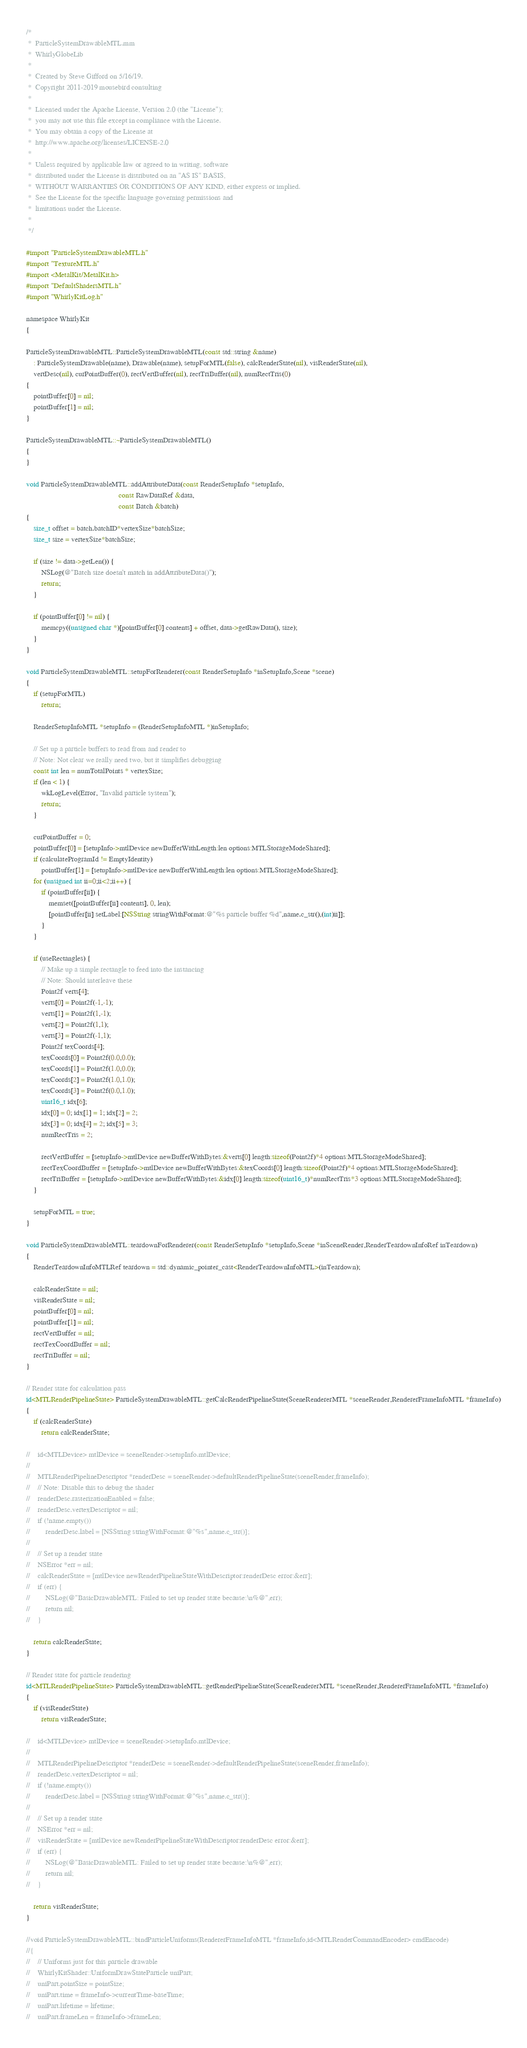<code> <loc_0><loc_0><loc_500><loc_500><_ObjectiveC_>/*
 *  ParticleSystemDrawableMTL.mm
 *  WhirlyGlobeLib
 *
 *  Created by Steve Gifford on 5/16/19.
 *  Copyright 2011-2019 mousebird consulting
 *
 *  Licensed under the Apache License, Version 2.0 (the "License");
 *  you may not use this file except in compliance with the License.
 *  You may obtain a copy of the License at
 *  http://www.apache.org/licenses/LICENSE-2.0
 *
 *  Unless required by applicable law or agreed to in writing, software
 *  distributed under the License is distributed on an "AS IS" BASIS,
 *  WITHOUT WARRANTIES OR CONDITIONS OF ANY KIND, either express or implied.
 *  See the License for the specific language governing permissions and
 *  limitations under the License.
 *
 */

#import "ParticleSystemDrawableMTL.h"
#import "TextureMTL.h"
#import <MetalKit/MetalKit.h>
#import "DefaultShadersMTL.h"
#import "WhirlyKitLog.h"

namespace WhirlyKit
{

ParticleSystemDrawableMTL::ParticleSystemDrawableMTL(const std::string &name)
    : ParticleSystemDrawable(name), Drawable(name), setupForMTL(false), calcRenderState(nil), visRenderState(nil),
    vertDesc(nil), curPointBuffer(0), rectVertBuffer(nil), rectTriBuffer(nil), numRectTris(0)
{
    pointBuffer[0] = nil;
    pointBuffer[1] = nil;
}

ParticleSystemDrawableMTL::~ParticleSystemDrawableMTL()
{
}

void ParticleSystemDrawableMTL::addAttributeData(const RenderSetupInfo *setupInfo,
                                                 const RawDataRef &data,
                                                 const Batch &batch)
{
    size_t offset = batch.batchID*vertexSize*batchSize;
    size_t size = vertexSize*batchSize;
    
    if (size != data->getLen()) {
        NSLog(@"Batch size doesn't match in addAttributeData()");
        return;
    }
    
    if (pointBuffer[0] != nil) {
        memcpy((unsigned char *)[pointBuffer[0] contents] + offset, data->getRawData(), size);
    }
}

void ParticleSystemDrawableMTL::setupForRenderer(const RenderSetupInfo *inSetupInfo,Scene *scene)
{
    if (setupForMTL)
        return;

    RenderSetupInfoMTL *setupInfo = (RenderSetupInfoMTL *)inSetupInfo;
    
    // Set up a particle buffers to read from and render to
    // Note: Not clear we really need two, but it simplifies debugging
    const int len = numTotalPoints * vertexSize;
    if (len < 1) {
        wkLogLevel(Error, "Invalid particle system");
        return;
    }
    
    curPointBuffer = 0;
    pointBuffer[0] = [setupInfo->mtlDevice newBufferWithLength:len options:MTLStorageModeShared];
    if (calculateProgramId != EmptyIdentity)
        pointBuffer[1] = [setupInfo->mtlDevice newBufferWithLength:len options:MTLStorageModeShared];
    for (unsigned int ii=0;ii<2;ii++) {
        if (pointBuffer[ii]) {
            memset([pointBuffer[ii] contents], 0, len);
            [pointBuffer[ii] setLabel:[NSString stringWithFormat:@"%s particle buffer %d",name.c_str(),(int)ii]];
        }
    }
    
    if (useRectangles) {
        // Make up a simple rectangle to feed into the instancing
        // Note: Should interleave these
        Point2f verts[4];
        verts[0] = Point2f(-1,-1);
        verts[1] = Point2f(1,-1);
        verts[2] = Point2f(1,1);
        verts[3] = Point2f(-1,1);
        Point2f texCoords[4];
        texCoords[0] = Point2f(0.0,0.0);
        texCoords[1] = Point2f(1.0,0.0);
        texCoords[2] = Point2f(1.0,1.0);
        texCoords[3] = Point2f(0.0,1.0);
        uint16_t idx[6];
        idx[0] = 0; idx[1] = 1; idx[2] = 2;
        idx[3] = 0; idx[4] = 2; idx[5] = 3;
        numRectTris = 2;
        
        rectVertBuffer = [setupInfo->mtlDevice newBufferWithBytes:&verts[0] length:sizeof(Point2f)*4 options:MTLStorageModeShared];
        rectTexCoordBuffer = [setupInfo->mtlDevice newBufferWithBytes:&texCoords[0] length:sizeof(Point2f)*4 options:MTLStorageModeShared];
        rectTriBuffer = [setupInfo->mtlDevice newBufferWithBytes:&idx[0] length:sizeof(uint16_t)*numRectTris*3 options:MTLStorageModeShared];
    }

    setupForMTL = true;
}

void ParticleSystemDrawableMTL::teardownForRenderer(const RenderSetupInfo *setupInfo,Scene *inSceneRender,RenderTeardownInfoRef inTeardown)
{
    RenderTeardownInfoMTLRef teardown = std::dynamic_pointer_cast<RenderTeardownInfoMTL>(inTeardown);

    calcRenderState = nil;
    visRenderState = nil;
    pointBuffer[0] = nil;
    pointBuffer[1] = nil;
    rectVertBuffer = nil;
    rectTexCoordBuffer = nil;
    rectTriBuffer = nil;
}
    
// Render state for calculation pass
id<MTLRenderPipelineState> ParticleSystemDrawableMTL::getCalcRenderPipelineState(SceneRendererMTL *sceneRender,RendererFrameInfoMTL *frameInfo)
{
    if (calcRenderState)
        return calcRenderState;
    
//    id<MTLDevice> mtlDevice = sceneRender->setupInfo.mtlDevice;
//    
//    MTLRenderPipelineDescriptor *renderDesc = sceneRender->defaultRenderPipelineState(sceneRender,frameInfo);
//    // Note: Disable this to debug the shader
//    renderDesc.rasterizationEnabled = false;
//    renderDesc.vertexDescriptor = nil;
//    if (!name.empty())
//        renderDesc.label = [NSString stringWithFormat:@"%s",name.c_str()];
//    
//    // Set up a render state
//    NSError *err = nil;
//    calcRenderState = [mtlDevice newRenderPipelineStateWithDescriptor:renderDesc error:&err];
//    if (err) {
//        NSLog(@"BasicDrawableMTL: Failed to set up render state because:\n%@",err);
//        return nil;
//    }
    
    return calcRenderState;
}
    
// Render state for particle rendering
id<MTLRenderPipelineState> ParticleSystemDrawableMTL::getRenderPipelineState(SceneRendererMTL *sceneRender,RendererFrameInfoMTL *frameInfo)
{
    if (visRenderState)
        return visRenderState;
    
//    id<MTLDevice> mtlDevice = sceneRender->setupInfo.mtlDevice;
//
//    MTLRenderPipelineDescriptor *renderDesc = sceneRender->defaultRenderPipelineState(sceneRender,frameInfo);
//    renderDesc.vertexDescriptor = nil;
//    if (!name.empty())
//        renderDesc.label = [NSString stringWithFormat:@"%s",name.c_str()];
//
//    // Set up a render state
//    NSError *err = nil;
//    visRenderState = [mtlDevice newRenderPipelineStateWithDescriptor:renderDesc error:&err];
//    if (err) {
//        NSLog(@"BasicDrawableMTL: Failed to set up render state because:\n%@",err);
//        return nil;
//    }
    
    return visRenderState;
}
    
//void ParticleSystemDrawableMTL::bindParticleUniforms(RendererFrameInfoMTL *frameInfo,id<MTLRenderCommandEncoder> cmdEncode)
//{
//    // Uniforms just for this particle drawable
//    WhirlyKitShader::UniformDrawStateParticle uniPart;
//    uniPart.pointSize = pointSize;
//    uniPart.time = frameInfo->currentTime-baseTime;
//    uniPart.lifetime = lifetime;
//    uniPart.frameLen = frameInfo->frameLen;</code> 